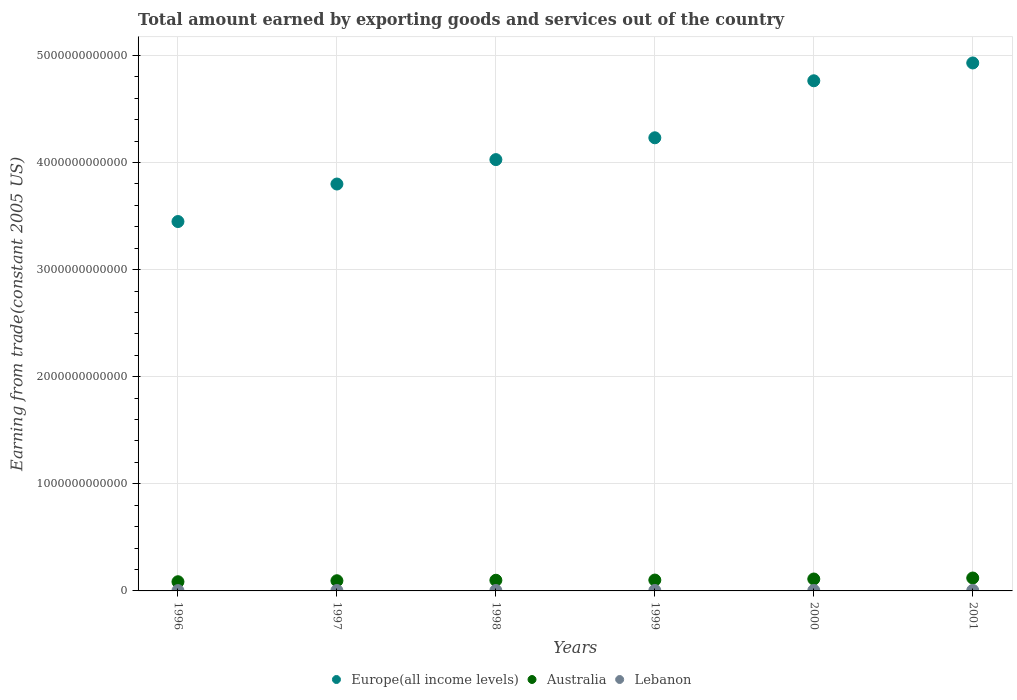Is the number of dotlines equal to the number of legend labels?
Offer a terse response. Yes. What is the total amount earned by exporting goods and services in Lebanon in 2000?
Ensure brevity in your answer.  4.23e+09. Across all years, what is the maximum total amount earned by exporting goods and services in Lebanon?
Provide a succinct answer. 4.94e+09. Across all years, what is the minimum total amount earned by exporting goods and services in Lebanon?
Make the answer very short. 2.96e+09. In which year was the total amount earned by exporting goods and services in Europe(all income levels) minimum?
Provide a succinct answer. 1996. What is the total total amount earned by exporting goods and services in Australia in the graph?
Offer a terse response. 6.13e+11. What is the difference between the total amount earned by exporting goods and services in Lebanon in 2000 and that in 2001?
Your response must be concise. -7.10e+08. What is the difference between the total amount earned by exporting goods and services in Europe(all income levels) in 1998 and the total amount earned by exporting goods and services in Australia in 2000?
Give a very brief answer. 3.92e+12. What is the average total amount earned by exporting goods and services in Lebanon per year?
Offer a very short reply. 4.00e+09. In the year 1998, what is the difference between the total amount earned by exporting goods and services in Australia and total amount earned by exporting goods and services in Europe(all income levels)?
Ensure brevity in your answer.  -3.93e+12. In how many years, is the total amount earned by exporting goods and services in Lebanon greater than 3200000000000 US$?
Your answer should be very brief. 0. What is the ratio of the total amount earned by exporting goods and services in Europe(all income levels) in 1996 to that in 1997?
Provide a succinct answer. 0.91. Is the total amount earned by exporting goods and services in Australia in 1999 less than that in 2000?
Give a very brief answer. Yes. What is the difference between the highest and the second highest total amount earned by exporting goods and services in Lebanon?
Offer a very short reply. 7.10e+08. What is the difference between the highest and the lowest total amount earned by exporting goods and services in Australia?
Provide a succinct answer. 3.48e+1. In how many years, is the total amount earned by exporting goods and services in Australia greater than the average total amount earned by exporting goods and services in Australia taken over all years?
Provide a short and direct response. 2. How many dotlines are there?
Provide a short and direct response. 3. How many years are there in the graph?
Provide a succinct answer. 6. What is the difference between two consecutive major ticks on the Y-axis?
Keep it short and to the point. 1.00e+12. Are the values on the major ticks of Y-axis written in scientific E-notation?
Offer a very short reply. No. Does the graph contain any zero values?
Your answer should be very brief. No. Where does the legend appear in the graph?
Ensure brevity in your answer.  Bottom center. What is the title of the graph?
Keep it short and to the point. Total amount earned by exporting goods and services out of the country. What is the label or title of the Y-axis?
Your answer should be very brief. Earning from trade(constant 2005 US). What is the Earning from trade(constant 2005 US) of Europe(all income levels) in 1996?
Keep it short and to the point. 3.45e+12. What is the Earning from trade(constant 2005 US) of Australia in 1996?
Make the answer very short. 8.57e+1. What is the Earning from trade(constant 2005 US) in Lebanon in 1996?
Give a very brief answer. 2.96e+09. What is the Earning from trade(constant 2005 US) of Europe(all income levels) in 1997?
Offer a very short reply. 3.80e+12. What is the Earning from trade(constant 2005 US) in Australia in 1997?
Your answer should be compact. 9.51e+1. What is the Earning from trade(constant 2005 US) in Lebanon in 1997?
Your answer should be very brief. 3.76e+09. What is the Earning from trade(constant 2005 US) in Europe(all income levels) in 1998?
Ensure brevity in your answer.  4.03e+12. What is the Earning from trade(constant 2005 US) of Australia in 1998?
Ensure brevity in your answer.  9.95e+1. What is the Earning from trade(constant 2005 US) of Lebanon in 1998?
Provide a succinct answer. 3.95e+09. What is the Earning from trade(constant 2005 US) of Europe(all income levels) in 1999?
Ensure brevity in your answer.  4.23e+12. What is the Earning from trade(constant 2005 US) in Australia in 1999?
Give a very brief answer. 1.01e+11. What is the Earning from trade(constant 2005 US) of Lebanon in 1999?
Your response must be concise. 4.16e+09. What is the Earning from trade(constant 2005 US) in Europe(all income levels) in 2000?
Make the answer very short. 4.76e+12. What is the Earning from trade(constant 2005 US) in Australia in 2000?
Your response must be concise. 1.11e+11. What is the Earning from trade(constant 2005 US) of Lebanon in 2000?
Your response must be concise. 4.23e+09. What is the Earning from trade(constant 2005 US) in Europe(all income levels) in 2001?
Offer a terse response. 4.93e+12. What is the Earning from trade(constant 2005 US) of Australia in 2001?
Provide a succinct answer. 1.21e+11. What is the Earning from trade(constant 2005 US) of Lebanon in 2001?
Provide a short and direct response. 4.94e+09. Across all years, what is the maximum Earning from trade(constant 2005 US) of Europe(all income levels)?
Give a very brief answer. 4.93e+12. Across all years, what is the maximum Earning from trade(constant 2005 US) in Australia?
Offer a very short reply. 1.21e+11. Across all years, what is the maximum Earning from trade(constant 2005 US) in Lebanon?
Provide a succinct answer. 4.94e+09. Across all years, what is the minimum Earning from trade(constant 2005 US) in Europe(all income levels)?
Your answer should be compact. 3.45e+12. Across all years, what is the minimum Earning from trade(constant 2005 US) in Australia?
Ensure brevity in your answer.  8.57e+1. Across all years, what is the minimum Earning from trade(constant 2005 US) of Lebanon?
Give a very brief answer. 2.96e+09. What is the total Earning from trade(constant 2005 US) in Europe(all income levels) in the graph?
Make the answer very short. 2.52e+13. What is the total Earning from trade(constant 2005 US) of Australia in the graph?
Your response must be concise. 6.13e+11. What is the total Earning from trade(constant 2005 US) in Lebanon in the graph?
Offer a very short reply. 2.40e+1. What is the difference between the Earning from trade(constant 2005 US) in Europe(all income levels) in 1996 and that in 1997?
Your response must be concise. -3.50e+11. What is the difference between the Earning from trade(constant 2005 US) in Australia in 1996 and that in 1997?
Provide a short and direct response. -9.33e+09. What is the difference between the Earning from trade(constant 2005 US) in Lebanon in 1996 and that in 1997?
Offer a very short reply. -8.00e+08. What is the difference between the Earning from trade(constant 2005 US) in Europe(all income levels) in 1996 and that in 1998?
Provide a short and direct response. -5.78e+11. What is the difference between the Earning from trade(constant 2005 US) of Australia in 1996 and that in 1998?
Make the answer very short. -1.38e+1. What is the difference between the Earning from trade(constant 2005 US) in Lebanon in 1996 and that in 1998?
Keep it short and to the point. -9.92e+08. What is the difference between the Earning from trade(constant 2005 US) in Europe(all income levels) in 1996 and that in 1999?
Your answer should be very brief. -7.82e+11. What is the difference between the Earning from trade(constant 2005 US) of Australia in 1996 and that in 1999?
Offer a very short reply. -1.57e+1. What is the difference between the Earning from trade(constant 2005 US) of Lebanon in 1996 and that in 1999?
Provide a short and direct response. -1.21e+09. What is the difference between the Earning from trade(constant 2005 US) of Europe(all income levels) in 1996 and that in 2000?
Keep it short and to the point. -1.31e+12. What is the difference between the Earning from trade(constant 2005 US) of Australia in 1996 and that in 2000?
Make the answer very short. -2.55e+1. What is the difference between the Earning from trade(constant 2005 US) in Lebanon in 1996 and that in 2000?
Your answer should be compact. -1.27e+09. What is the difference between the Earning from trade(constant 2005 US) in Europe(all income levels) in 1996 and that in 2001?
Keep it short and to the point. -1.48e+12. What is the difference between the Earning from trade(constant 2005 US) in Australia in 1996 and that in 2001?
Your answer should be compact. -3.48e+1. What is the difference between the Earning from trade(constant 2005 US) of Lebanon in 1996 and that in 2001?
Ensure brevity in your answer.  -1.98e+09. What is the difference between the Earning from trade(constant 2005 US) of Europe(all income levels) in 1997 and that in 1998?
Keep it short and to the point. -2.28e+11. What is the difference between the Earning from trade(constant 2005 US) in Australia in 1997 and that in 1998?
Make the answer very short. -4.45e+09. What is the difference between the Earning from trade(constant 2005 US) of Lebanon in 1997 and that in 1998?
Your answer should be very brief. -1.92e+08. What is the difference between the Earning from trade(constant 2005 US) in Europe(all income levels) in 1997 and that in 1999?
Give a very brief answer. -4.32e+11. What is the difference between the Earning from trade(constant 2005 US) of Australia in 1997 and that in 1999?
Keep it short and to the point. -6.36e+09. What is the difference between the Earning from trade(constant 2005 US) of Lebanon in 1997 and that in 1999?
Offer a very short reply. -4.05e+08. What is the difference between the Earning from trade(constant 2005 US) in Europe(all income levels) in 1997 and that in 2000?
Offer a terse response. -9.64e+11. What is the difference between the Earning from trade(constant 2005 US) in Australia in 1997 and that in 2000?
Your answer should be very brief. -1.62e+1. What is the difference between the Earning from trade(constant 2005 US) in Lebanon in 1997 and that in 2000?
Provide a succinct answer. -4.71e+08. What is the difference between the Earning from trade(constant 2005 US) of Europe(all income levels) in 1997 and that in 2001?
Provide a short and direct response. -1.13e+12. What is the difference between the Earning from trade(constant 2005 US) in Australia in 1997 and that in 2001?
Your answer should be very brief. -2.54e+1. What is the difference between the Earning from trade(constant 2005 US) in Lebanon in 1997 and that in 2001?
Keep it short and to the point. -1.18e+09. What is the difference between the Earning from trade(constant 2005 US) in Europe(all income levels) in 1998 and that in 1999?
Your answer should be compact. -2.04e+11. What is the difference between the Earning from trade(constant 2005 US) in Australia in 1998 and that in 1999?
Provide a succinct answer. -1.91e+09. What is the difference between the Earning from trade(constant 2005 US) in Lebanon in 1998 and that in 1999?
Make the answer very short. -2.13e+08. What is the difference between the Earning from trade(constant 2005 US) in Europe(all income levels) in 1998 and that in 2000?
Give a very brief answer. -7.36e+11. What is the difference between the Earning from trade(constant 2005 US) in Australia in 1998 and that in 2000?
Provide a short and direct response. -1.18e+1. What is the difference between the Earning from trade(constant 2005 US) of Lebanon in 1998 and that in 2000?
Your answer should be very brief. -2.80e+08. What is the difference between the Earning from trade(constant 2005 US) in Europe(all income levels) in 1998 and that in 2001?
Provide a short and direct response. -9.02e+11. What is the difference between the Earning from trade(constant 2005 US) of Australia in 1998 and that in 2001?
Keep it short and to the point. -2.10e+1. What is the difference between the Earning from trade(constant 2005 US) in Lebanon in 1998 and that in 2001?
Your response must be concise. -9.90e+08. What is the difference between the Earning from trade(constant 2005 US) in Europe(all income levels) in 1999 and that in 2000?
Your answer should be compact. -5.32e+11. What is the difference between the Earning from trade(constant 2005 US) of Australia in 1999 and that in 2000?
Ensure brevity in your answer.  -9.86e+09. What is the difference between the Earning from trade(constant 2005 US) of Lebanon in 1999 and that in 2000?
Your answer should be very brief. -6.66e+07. What is the difference between the Earning from trade(constant 2005 US) of Europe(all income levels) in 1999 and that in 2001?
Offer a terse response. -6.99e+11. What is the difference between the Earning from trade(constant 2005 US) of Australia in 1999 and that in 2001?
Offer a terse response. -1.91e+1. What is the difference between the Earning from trade(constant 2005 US) of Lebanon in 1999 and that in 2001?
Make the answer very short. -7.77e+08. What is the difference between the Earning from trade(constant 2005 US) in Europe(all income levels) in 2000 and that in 2001?
Provide a short and direct response. -1.66e+11. What is the difference between the Earning from trade(constant 2005 US) in Australia in 2000 and that in 2001?
Give a very brief answer. -9.23e+09. What is the difference between the Earning from trade(constant 2005 US) of Lebanon in 2000 and that in 2001?
Give a very brief answer. -7.10e+08. What is the difference between the Earning from trade(constant 2005 US) of Europe(all income levels) in 1996 and the Earning from trade(constant 2005 US) of Australia in 1997?
Make the answer very short. 3.35e+12. What is the difference between the Earning from trade(constant 2005 US) in Europe(all income levels) in 1996 and the Earning from trade(constant 2005 US) in Lebanon in 1997?
Offer a very short reply. 3.45e+12. What is the difference between the Earning from trade(constant 2005 US) of Australia in 1996 and the Earning from trade(constant 2005 US) of Lebanon in 1997?
Provide a short and direct response. 8.20e+1. What is the difference between the Earning from trade(constant 2005 US) in Europe(all income levels) in 1996 and the Earning from trade(constant 2005 US) in Australia in 1998?
Offer a very short reply. 3.35e+12. What is the difference between the Earning from trade(constant 2005 US) in Europe(all income levels) in 1996 and the Earning from trade(constant 2005 US) in Lebanon in 1998?
Your answer should be very brief. 3.45e+12. What is the difference between the Earning from trade(constant 2005 US) in Australia in 1996 and the Earning from trade(constant 2005 US) in Lebanon in 1998?
Offer a very short reply. 8.18e+1. What is the difference between the Earning from trade(constant 2005 US) of Europe(all income levels) in 1996 and the Earning from trade(constant 2005 US) of Australia in 1999?
Keep it short and to the point. 3.35e+12. What is the difference between the Earning from trade(constant 2005 US) in Europe(all income levels) in 1996 and the Earning from trade(constant 2005 US) in Lebanon in 1999?
Give a very brief answer. 3.44e+12. What is the difference between the Earning from trade(constant 2005 US) of Australia in 1996 and the Earning from trade(constant 2005 US) of Lebanon in 1999?
Your answer should be compact. 8.16e+1. What is the difference between the Earning from trade(constant 2005 US) of Europe(all income levels) in 1996 and the Earning from trade(constant 2005 US) of Australia in 2000?
Keep it short and to the point. 3.34e+12. What is the difference between the Earning from trade(constant 2005 US) of Europe(all income levels) in 1996 and the Earning from trade(constant 2005 US) of Lebanon in 2000?
Offer a terse response. 3.44e+12. What is the difference between the Earning from trade(constant 2005 US) of Australia in 1996 and the Earning from trade(constant 2005 US) of Lebanon in 2000?
Provide a succinct answer. 8.15e+1. What is the difference between the Earning from trade(constant 2005 US) in Europe(all income levels) in 1996 and the Earning from trade(constant 2005 US) in Australia in 2001?
Your answer should be compact. 3.33e+12. What is the difference between the Earning from trade(constant 2005 US) of Europe(all income levels) in 1996 and the Earning from trade(constant 2005 US) of Lebanon in 2001?
Provide a succinct answer. 3.44e+12. What is the difference between the Earning from trade(constant 2005 US) of Australia in 1996 and the Earning from trade(constant 2005 US) of Lebanon in 2001?
Keep it short and to the point. 8.08e+1. What is the difference between the Earning from trade(constant 2005 US) in Europe(all income levels) in 1997 and the Earning from trade(constant 2005 US) in Australia in 1998?
Offer a terse response. 3.70e+12. What is the difference between the Earning from trade(constant 2005 US) in Europe(all income levels) in 1997 and the Earning from trade(constant 2005 US) in Lebanon in 1998?
Give a very brief answer. 3.80e+12. What is the difference between the Earning from trade(constant 2005 US) of Australia in 1997 and the Earning from trade(constant 2005 US) of Lebanon in 1998?
Provide a succinct answer. 9.11e+1. What is the difference between the Earning from trade(constant 2005 US) of Europe(all income levels) in 1997 and the Earning from trade(constant 2005 US) of Australia in 1999?
Your answer should be very brief. 3.70e+12. What is the difference between the Earning from trade(constant 2005 US) of Europe(all income levels) in 1997 and the Earning from trade(constant 2005 US) of Lebanon in 1999?
Provide a succinct answer. 3.80e+12. What is the difference between the Earning from trade(constant 2005 US) of Australia in 1997 and the Earning from trade(constant 2005 US) of Lebanon in 1999?
Provide a succinct answer. 9.09e+1. What is the difference between the Earning from trade(constant 2005 US) in Europe(all income levels) in 1997 and the Earning from trade(constant 2005 US) in Australia in 2000?
Provide a short and direct response. 3.69e+12. What is the difference between the Earning from trade(constant 2005 US) of Europe(all income levels) in 1997 and the Earning from trade(constant 2005 US) of Lebanon in 2000?
Your answer should be very brief. 3.80e+12. What is the difference between the Earning from trade(constant 2005 US) in Australia in 1997 and the Earning from trade(constant 2005 US) in Lebanon in 2000?
Give a very brief answer. 9.08e+1. What is the difference between the Earning from trade(constant 2005 US) of Europe(all income levels) in 1997 and the Earning from trade(constant 2005 US) of Australia in 2001?
Make the answer very short. 3.68e+12. What is the difference between the Earning from trade(constant 2005 US) in Europe(all income levels) in 1997 and the Earning from trade(constant 2005 US) in Lebanon in 2001?
Keep it short and to the point. 3.79e+12. What is the difference between the Earning from trade(constant 2005 US) in Australia in 1997 and the Earning from trade(constant 2005 US) in Lebanon in 2001?
Your answer should be compact. 9.01e+1. What is the difference between the Earning from trade(constant 2005 US) of Europe(all income levels) in 1998 and the Earning from trade(constant 2005 US) of Australia in 1999?
Provide a short and direct response. 3.93e+12. What is the difference between the Earning from trade(constant 2005 US) in Europe(all income levels) in 1998 and the Earning from trade(constant 2005 US) in Lebanon in 1999?
Ensure brevity in your answer.  4.02e+12. What is the difference between the Earning from trade(constant 2005 US) of Australia in 1998 and the Earning from trade(constant 2005 US) of Lebanon in 1999?
Ensure brevity in your answer.  9.53e+1. What is the difference between the Earning from trade(constant 2005 US) of Europe(all income levels) in 1998 and the Earning from trade(constant 2005 US) of Australia in 2000?
Give a very brief answer. 3.92e+12. What is the difference between the Earning from trade(constant 2005 US) of Europe(all income levels) in 1998 and the Earning from trade(constant 2005 US) of Lebanon in 2000?
Your answer should be compact. 4.02e+12. What is the difference between the Earning from trade(constant 2005 US) of Australia in 1998 and the Earning from trade(constant 2005 US) of Lebanon in 2000?
Make the answer very short. 9.53e+1. What is the difference between the Earning from trade(constant 2005 US) of Europe(all income levels) in 1998 and the Earning from trade(constant 2005 US) of Australia in 2001?
Make the answer very short. 3.91e+12. What is the difference between the Earning from trade(constant 2005 US) of Europe(all income levels) in 1998 and the Earning from trade(constant 2005 US) of Lebanon in 2001?
Provide a short and direct response. 4.02e+12. What is the difference between the Earning from trade(constant 2005 US) of Australia in 1998 and the Earning from trade(constant 2005 US) of Lebanon in 2001?
Give a very brief answer. 9.46e+1. What is the difference between the Earning from trade(constant 2005 US) of Europe(all income levels) in 1999 and the Earning from trade(constant 2005 US) of Australia in 2000?
Your answer should be very brief. 4.12e+12. What is the difference between the Earning from trade(constant 2005 US) of Europe(all income levels) in 1999 and the Earning from trade(constant 2005 US) of Lebanon in 2000?
Your answer should be compact. 4.23e+12. What is the difference between the Earning from trade(constant 2005 US) in Australia in 1999 and the Earning from trade(constant 2005 US) in Lebanon in 2000?
Your response must be concise. 9.72e+1. What is the difference between the Earning from trade(constant 2005 US) in Europe(all income levels) in 1999 and the Earning from trade(constant 2005 US) in Australia in 2001?
Your response must be concise. 4.11e+12. What is the difference between the Earning from trade(constant 2005 US) of Europe(all income levels) in 1999 and the Earning from trade(constant 2005 US) of Lebanon in 2001?
Offer a terse response. 4.23e+12. What is the difference between the Earning from trade(constant 2005 US) of Australia in 1999 and the Earning from trade(constant 2005 US) of Lebanon in 2001?
Your response must be concise. 9.65e+1. What is the difference between the Earning from trade(constant 2005 US) in Europe(all income levels) in 2000 and the Earning from trade(constant 2005 US) in Australia in 2001?
Your response must be concise. 4.64e+12. What is the difference between the Earning from trade(constant 2005 US) of Europe(all income levels) in 2000 and the Earning from trade(constant 2005 US) of Lebanon in 2001?
Make the answer very short. 4.76e+12. What is the difference between the Earning from trade(constant 2005 US) of Australia in 2000 and the Earning from trade(constant 2005 US) of Lebanon in 2001?
Your answer should be compact. 1.06e+11. What is the average Earning from trade(constant 2005 US) in Europe(all income levels) per year?
Your response must be concise. 4.20e+12. What is the average Earning from trade(constant 2005 US) of Australia per year?
Give a very brief answer. 1.02e+11. What is the average Earning from trade(constant 2005 US) in Lebanon per year?
Your answer should be very brief. 4.00e+09. In the year 1996, what is the difference between the Earning from trade(constant 2005 US) in Europe(all income levels) and Earning from trade(constant 2005 US) in Australia?
Ensure brevity in your answer.  3.36e+12. In the year 1996, what is the difference between the Earning from trade(constant 2005 US) in Europe(all income levels) and Earning from trade(constant 2005 US) in Lebanon?
Keep it short and to the point. 3.45e+12. In the year 1996, what is the difference between the Earning from trade(constant 2005 US) of Australia and Earning from trade(constant 2005 US) of Lebanon?
Offer a terse response. 8.28e+1. In the year 1997, what is the difference between the Earning from trade(constant 2005 US) in Europe(all income levels) and Earning from trade(constant 2005 US) in Australia?
Your answer should be compact. 3.70e+12. In the year 1997, what is the difference between the Earning from trade(constant 2005 US) of Europe(all income levels) and Earning from trade(constant 2005 US) of Lebanon?
Ensure brevity in your answer.  3.80e+12. In the year 1997, what is the difference between the Earning from trade(constant 2005 US) in Australia and Earning from trade(constant 2005 US) in Lebanon?
Offer a very short reply. 9.13e+1. In the year 1998, what is the difference between the Earning from trade(constant 2005 US) of Europe(all income levels) and Earning from trade(constant 2005 US) of Australia?
Make the answer very short. 3.93e+12. In the year 1998, what is the difference between the Earning from trade(constant 2005 US) of Europe(all income levels) and Earning from trade(constant 2005 US) of Lebanon?
Offer a very short reply. 4.02e+12. In the year 1998, what is the difference between the Earning from trade(constant 2005 US) of Australia and Earning from trade(constant 2005 US) of Lebanon?
Your response must be concise. 9.56e+1. In the year 1999, what is the difference between the Earning from trade(constant 2005 US) in Europe(all income levels) and Earning from trade(constant 2005 US) in Australia?
Offer a terse response. 4.13e+12. In the year 1999, what is the difference between the Earning from trade(constant 2005 US) in Europe(all income levels) and Earning from trade(constant 2005 US) in Lebanon?
Keep it short and to the point. 4.23e+12. In the year 1999, what is the difference between the Earning from trade(constant 2005 US) of Australia and Earning from trade(constant 2005 US) of Lebanon?
Keep it short and to the point. 9.73e+1. In the year 2000, what is the difference between the Earning from trade(constant 2005 US) of Europe(all income levels) and Earning from trade(constant 2005 US) of Australia?
Offer a very short reply. 4.65e+12. In the year 2000, what is the difference between the Earning from trade(constant 2005 US) of Europe(all income levels) and Earning from trade(constant 2005 US) of Lebanon?
Your answer should be compact. 4.76e+12. In the year 2000, what is the difference between the Earning from trade(constant 2005 US) of Australia and Earning from trade(constant 2005 US) of Lebanon?
Make the answer very short. 1.07e+11. In the year 2001, what is the difference between the Earning from trade(constant 2005 US) of Europe(all income levels) and Earning from trade(constant 2005 US) of Australia?
Your response must be concise. 4.81e+12. In the year 2001, what is the difference between the Earning from trade(constant 2005 US) of Europe(all income levels) and Earning from trade(constant 2005 US) of Lebanon?
Make the answer very short. 4.92e+12. In the year 2001, what is the difference between the Earning from trade(constant 2005 US) in Australia and Earning from trade(constant 2005 US) in Lebanon?
Provide a succinct answer. 1.16e+11. What is the ratio of the Earning from trade(constant 2005 US) of Europe(all income levels) in 1996 to that in 1997?
Your response must be concise. 0.91. What is the ratio of the Earning from trade(constant 2005 US) in Australia in 1996 to that in 1997?
Your answer should be very brief. 0.9. What is the ratio of the Earning from trade(constant 2005 US) of Lebanon in 1996 to that in 1997?
Your response must be concise. 0.79. What is the ratio of the Earning from trade(constant 2005 US) in Europe(all income levels) in 1996 to that in 1998?
Your response must be concise. 0.86. What is the ratio of the Earning from trade(constant 2005 US) of Australia in 1996 to that in 1998?
Make the answer very short. 0.86. What is the ratio of the Earning from trade(constant 2005 US) in Lebanon in 1996 to that in 1998?
Provide a succinct answer. 0.75. What is the ratio of the Earning from trade(constant 2005 US) of Europe(all income levels) in 1996 to that in 1999?
Provide a succinct answer. 0.82. What is the ratio of the Earning from trade(constant 2005 US) in Australia in 1996 to that in 1999?
Provide a succinct answer. 0.85. What is the ratio of the Earning from trade(constant 2005 US) of Lebanon in 1996 to that in 1999?
Your answer should be very brief. 0.71. What is the ratio of the Earning from trade(constant 2005 US) in Europe(all income levels) in 1996 to that in 2000?
Provide a short and direct response. 0.72. What is the ratio of the Earning from trade(constant 2005 US) in Australia in 1996 to that in 2000?
Keep it short and to the point. 0.77. What is the ratio of the Earning from trade(constant 2005 US) in Lebanon in 1996 to that in 2000?
Offer a very short reply. 0.7. What is the ratio of the Earning from trade(constant 2005 US) of Europe(all income levels) in 1996 to that in 2001?
Your answer should be very brief. 0.7. What is the ratio of the Earning from trade(constant 2005 US) of Australia in 1996 to that in 2001?
Ensure brevity in your answer.  0.71. What is the ratio of the Earning from trade(constant 2005 US) of Lebanon in 1996 to that in 2001?
Provide a short and direct response. 0.6. What is the ratio of the Earning from trade(constant 2005 US) of Europe(all income levels) in 1997 to that in 1998?
Give a very brief answer. 0.94. What is the ratio of the Earning from trade(constant 2005 US) of Australia in 1997 to that in 1998?
Ensure brevity in your answer.  0.96. What is the ratio of the Earning from trade(constant 2005 US) of Lebanon in 1997 to that in 1998?
Make the answer very short. 0.95. What is the ratio of the Earning from trade(constant 2005 US) in Europe(all income levels) in 1997 to that in 1999?
Give a very brief answer. 0.9. What is the ratio of the Earning from trade(constant 2005 US) in Australia in 1997 to that in 1999?
Provide a succinct answer. 0.94. What is the ratio of the Earning from trade(constant 2005 US) of Lebanon in 1997 to that in 1999?
Provide a succinct answer. 0.9. What is the ratio of the Earning from trade(constant 2005 US) in Europe(all income levels) in 1997 to that in 2000?
Ensure brevity in your answer.  0.8. What is the ratio of the Earning from trade(constant 2005 US) in Australia in 1997 to that in 2000?
Provide a succinct answer. 0.85. What is the ratio of the Earning from trade(constant 2005 US) of Lebanon in 1997 to that in 2000?
Provide a short and direct response. 0.89. What is the ratio of the Earning from trade(constant 2005 US) of Europe(all income levels) in 1997 to that in 2001?
Provide a short and direct response. 0.77. What is the ratio of the Earning from trade(constant 2005 US) of Australia in 1997 to that in 2001?
Give a very brief answer. 0.79. What is the ratio of the Earning from trade(constant 2005 US) of Lebanon in 1997 to that in 2001?
Offer a terse response. 0.76. What is the ratio of the Earning from trade(constant 2005 US) in Europe(all income levels) in 1998 to that in 1999?
Make the answer very short. 0.95. What is the ratio of the Earning from trade(constant 2005 US) of Australia in 1998 to that in 1999?
Offer a very short reply. 0.98. What is the ratio of the Earning from trade(constant 2005 US) of Lebanon in 1998 to that in 1999?
Offer a terse response. 0.95. What is the ratio of the Earning from trade(constant 2005 US) of Europe(all income levels) in 1998 to that in 2000?
Your answer should be compact. 0.85. What is the ratio of the Earning from trade(constant 2005 US) of Australia in 1998 to that in 2000?
Ensure brevity in your answer.  0.89. What is the ratio of the Earning from trade(constant 2005 US) of Lebanon in 1998 to that in 2000?
Offer a very short reply. 0.93. What is the ratio of the Earning from trade(constant 2005 US) of Europe(all income levels) in 1998 to that in 2001?
Keep it short and to the point. 0.82. What is the ratio of the Earning from trade(constant 2005 US) of Australia in 1998 to that in 2001?
Ensure brevity in your answer.  0.83. What is the ratio of the Earning from trade(constant 2005 US) in Lebanon in 1998 to that in 2001?
Give a very brief answer. 0.8. What is the ratio of the Earning from trade(constant 2005 US) of Europe(all income levels) in 1999 to that in 2000?
Offer a very short reply. 0.89. What is the ratio of the Earning from trade(constant 2005 US) in Australia in 1999 to that in 2000?
Your answer should be compact. 0.91. What is the ratio of the Earning from trade(constant 2005 US) in Lebanon in 1999 to that in 2000?
Provide a short and direct response. 0.98. What is the ratio of the Earning from trade(constant 2005 US) in Europe(all income levels) in 1999 to that in 2001?
Give a very brief answer. 0.86. What is the ratio of the Earning from trade(constant 2005 US) of Australia in 1999 to that in 2001?
Ensure brevity in your answer.  0.84. What is the ratio of the Earning from trade(constant 2005 US) of Lebanon in 1999 to that in 2001?
Make the answer very short. 0.84. What is the ratio of the Earning from trade(constant 2005 US) of Europe(all income levels) in 2000 to that in 2001?
Keep it short and to the point. 0.97. What is the ratio of the Earning from trade(constant 2005 US) of Australia in 2000 to that in 2001?
Offer a terse response. 0.92. What is the ratio of the Earning from trade(constant 2005 US) in Lebanon in 2000 to that in 2001?
Provide a short and direct response. 0.86. What is the difference between the highest and the second highest Earning from trade(constant 2005 US) in Europe(all income levels)?
Provide a short and direct response. 1.66e+11. What is the difference between the highest and the second highest Earning from trade(constant 2005 US) of Australia?
Give a very brief answer. 9.23e+09. What is the difference between the highest and the second highest Earning from trade(constant 2005 US) in Lebanon?
Your answer should be compact. 7.10e+08. What is the difference between the highest and the lowest Earning from trade(constant 2005 US) of Europe(all income levels)?
Offer a terse response. 1.48e+12. What is the difference between the highest and the lowest Earning from trade(constant 2005 US) in Australia?
Provide a short and direct response. 3.48e+1. What is the difference between the highest and the lowest Earning from trade(constant 2005 US) of Lebanon?
Ensure brevity in your answer.  1.98e+09. 